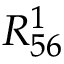Convert formula to latex. <formula><loc_0><loc_0><loc_500><loc_500>R _ { 5 6 } ^ { 1 }</formula> 